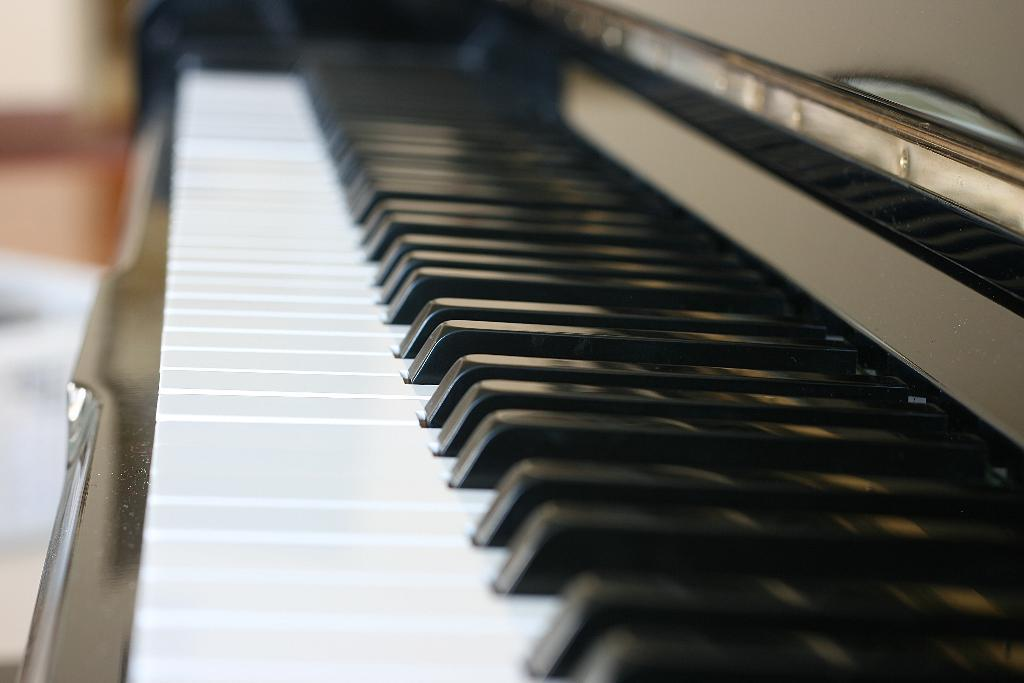What is the color of the musical keyboard in the image? The musical keyboard is black and white in color. Is there a mailbox near the musical keyboard in the image? There is no mention of a mailbox in the provided facts, so we cannot determine its presence in the image. 